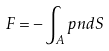Convert formula to latex. <formula><loc_0><loc_0><loc_500><loc_500>F = - \int _ { A } p n d S</formula> 